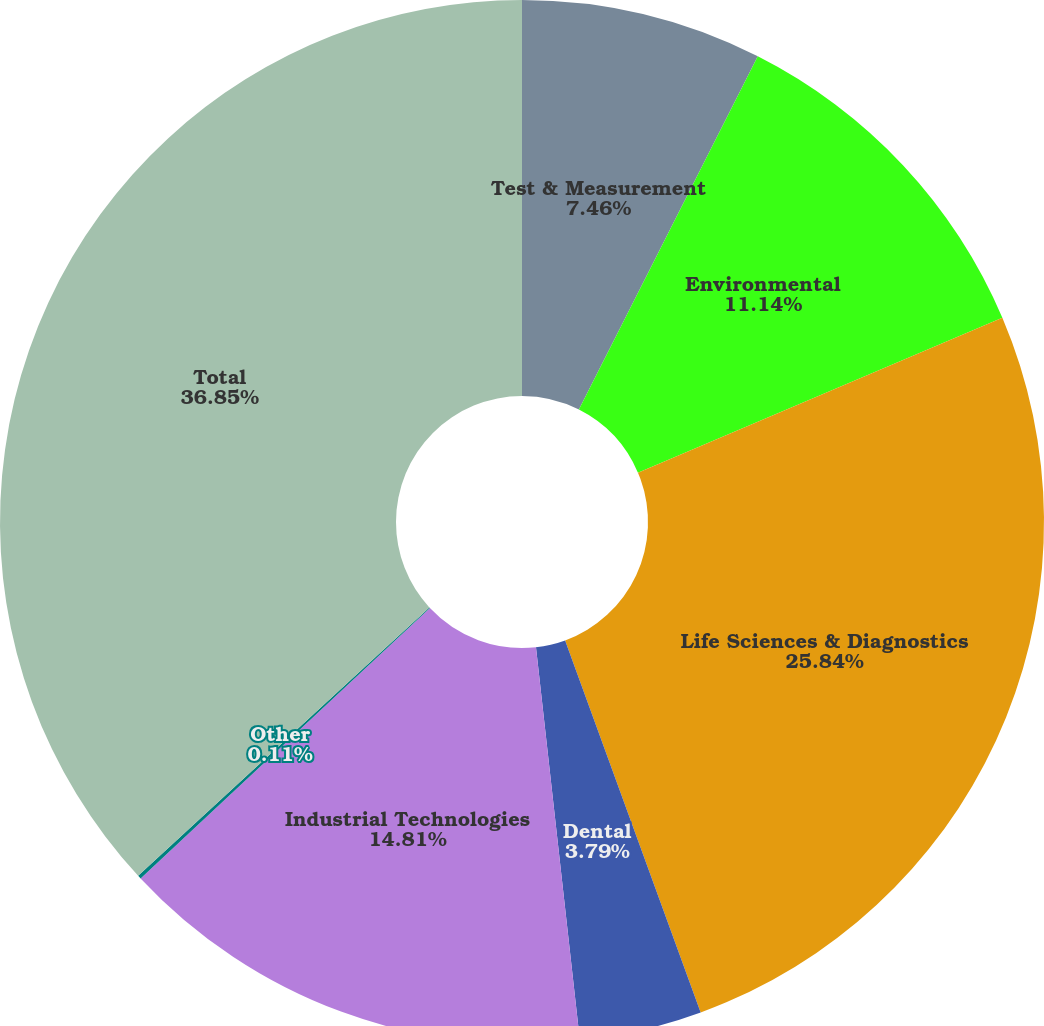<chart> <loc_0><loc_0><loc_500><loc_500><pie_chart><fcel>Test & Measurement<fcel>Environmental<fcel>Life Sciences & Diagnostics<fcel>Dental<fcel>Industrial Technologies<fcel>Other<fcel>Total<nl><fcel>7.46%<fcel>11.14%<fcel>25.84%<fcel>3.79%<fcel>14.81%<fcel>0.11%<fcel>36.85%<nl></chart> 